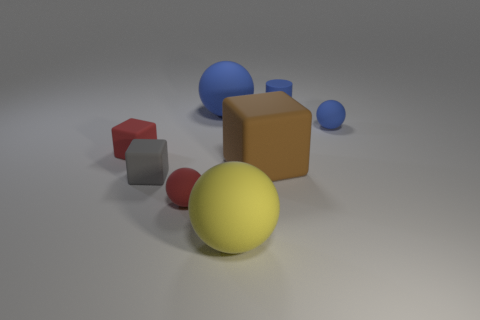Add 1 brown objects. How many objects exist? 9 Subtract all cylinders. How many objects are left? 7 Add 6 red blocks. How many red blocks are left? 7 Add 3 tiny cyan metal cylinders. How many tiny cyan metal cylinders exist? 3 Subtract 1 yellow spheres. How many objects are left? 7 Subtract all large blue rubber things. Subtract all big blue matte balls. How many objects are left? 6 